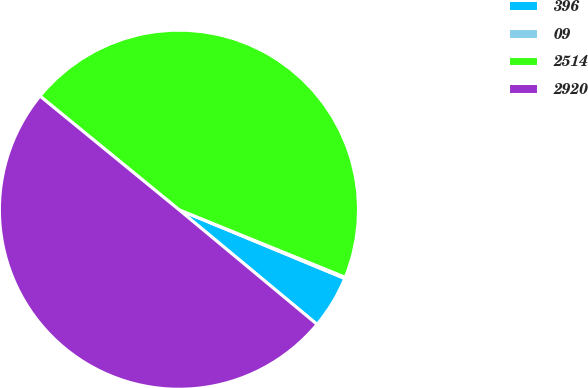Convert chart. <chart><loc_0><loc_0><loc_500><loc_500><pie_chart><fcel>396<fcel>09<fcel>2514<fcel>2920<nl><fcel>4.77%<fcel>0.12%<fcel>45.23%<fcel>49.88%<nl></chart> 